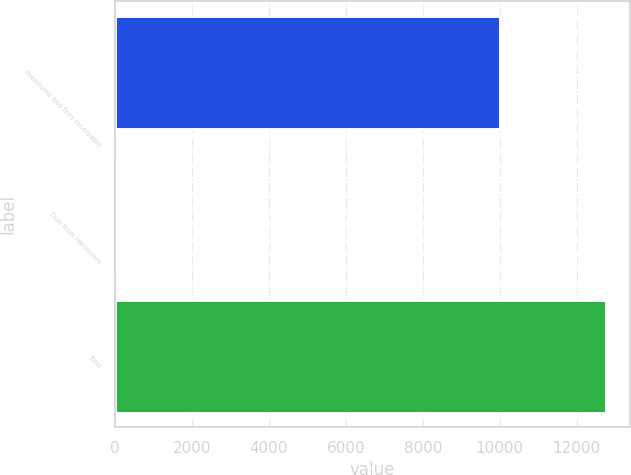Convert chart to OTSL. <chart><loc_0><loc_0><loc_500><loc_500><bar_chart><fcel>Premiums and fees receivable<fcel>Due from reinsurers<fcel>Total<nl><fcel>10006<fcel>20<fcel>12749<nl></chart> 